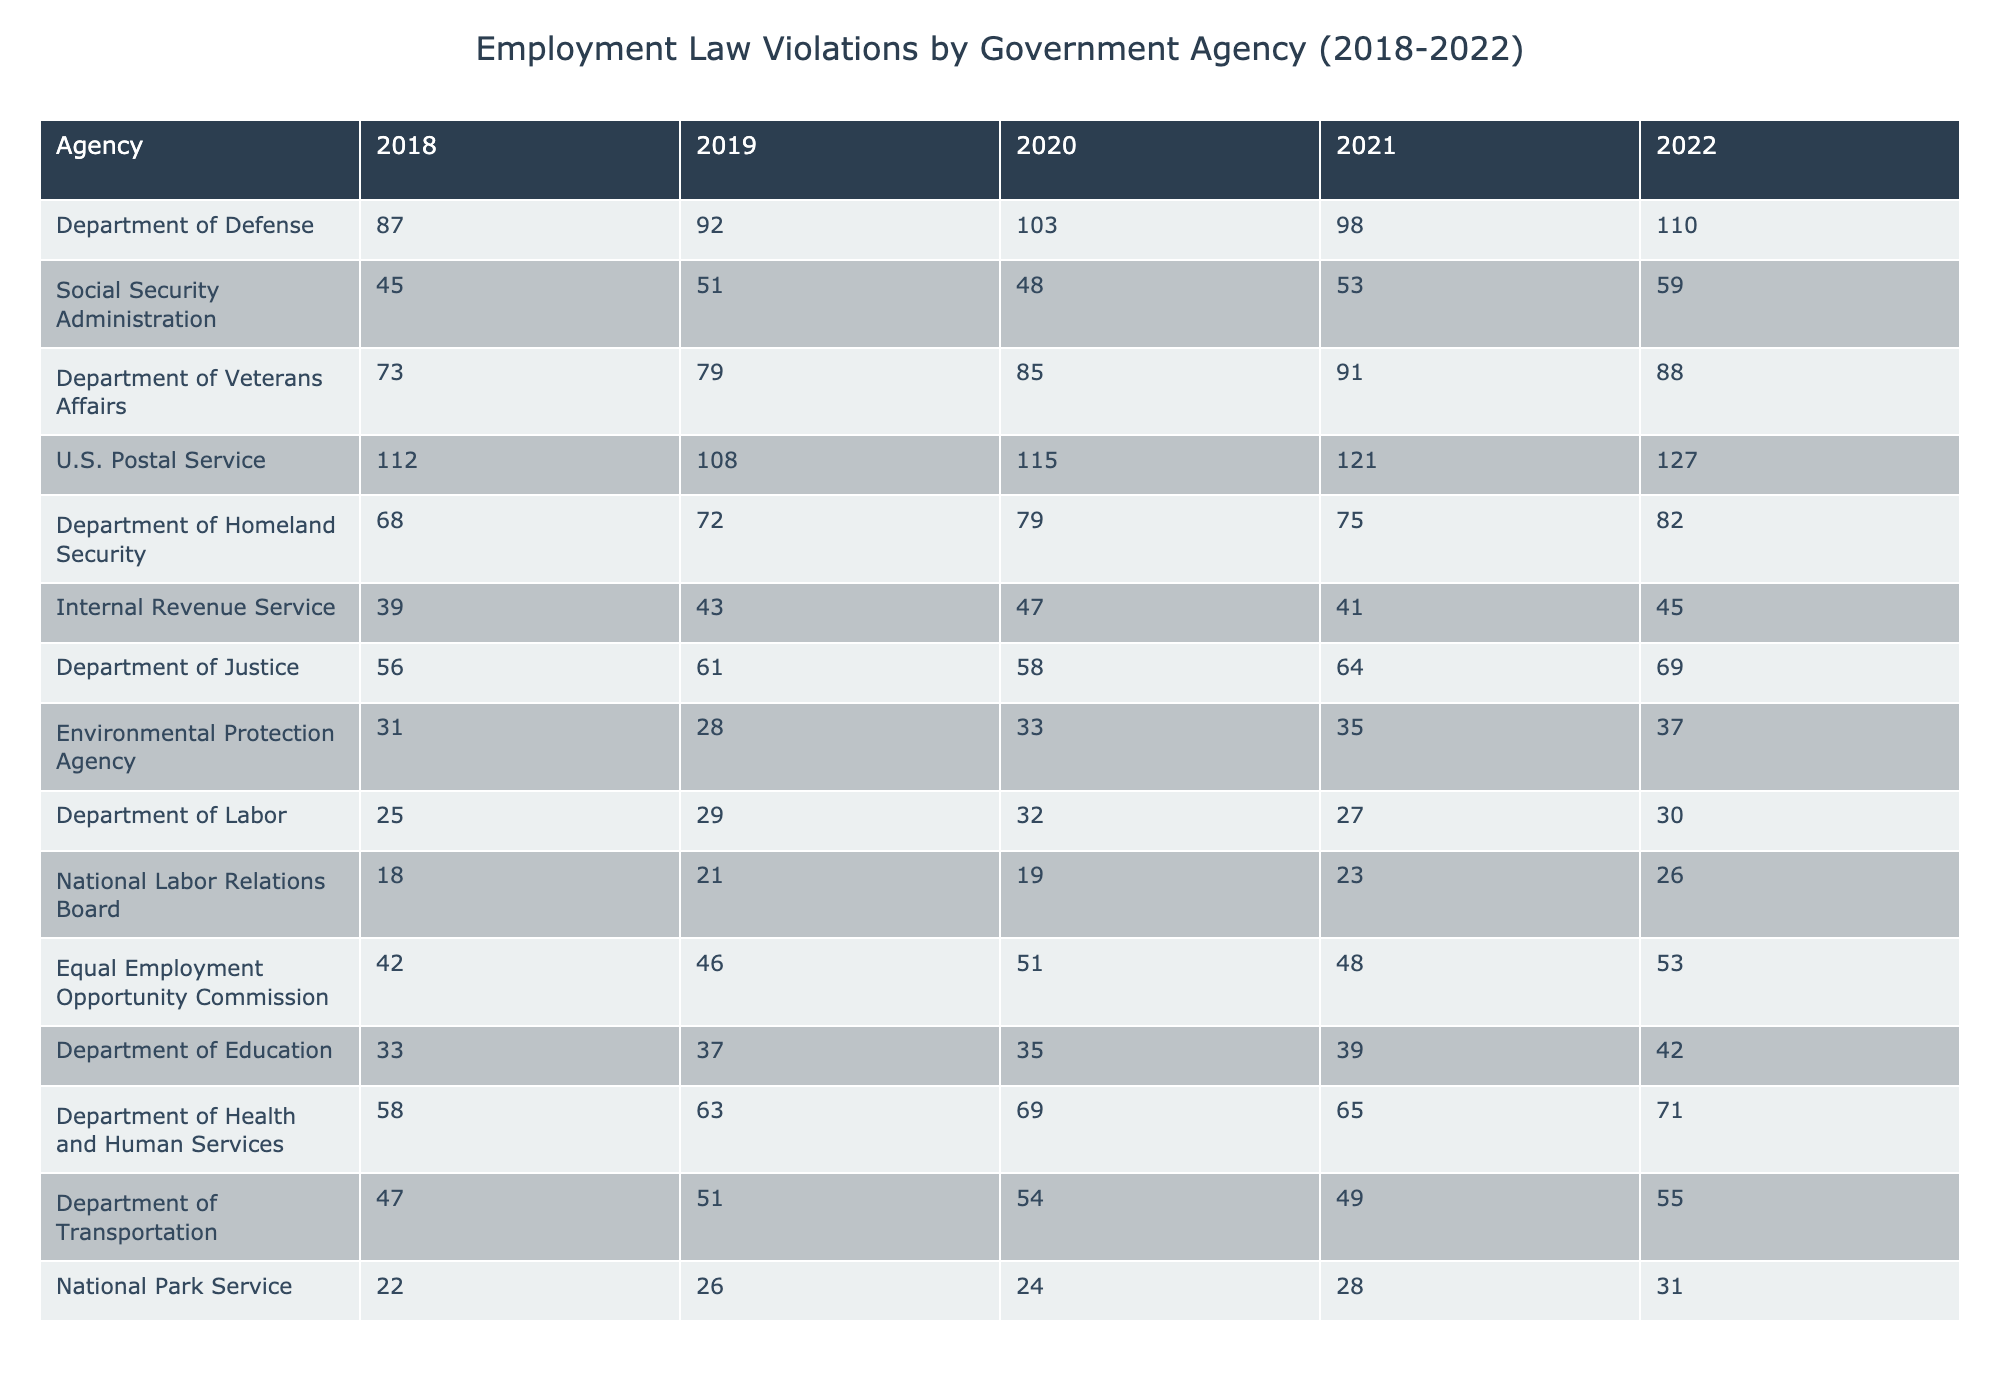What was the highest number of employment law violations reported by the U.S. Postal Service? Referring to the table, the highest number of violations reported by the U.S. Postal Service was 127 in 2022.
Answer: 127 Which agency had the lowest total of violations over the five years? Adding the violations for each agency from 2018 to 2022, the National Labor Relations Board had the lowest total with 105 violations.
Answer: National Labor Relations Board What was the average number of violations for the Department of Defense over the five years? The total number of violations for the Department of Defense from 2018 to 2022 is 490 (87 + 92 + 103 + 98 + 110). Dividing by 5 gives an average of 98.
Answer: 98 Did the Department of Labor see an increase or decrease in violations from 2018 to 2022? The Department of Labor had 25 violations in 2018 and 30 in 2022, showing an increase of 5 violations over the five years.
Answer: Increase What is the difference between the highest and lowest number of violations reported in 2021? The highest number of violations in 2021 was reported by the U.S. Postal Service (121), and the lowest was reported by the National Labor Relations Board (23). The difference is 121 - 23 = 98.
Answer: 98 In which years did the Department of Health and Human Services have more than 65 violations? The Department of Health and Human Services had violations exceeding 65 in the years 2020 (69), 2021 (65), and 2022 (71).
Answer: 2020, 2022 How many total violations were reported by the Environmental Protection Agency from 2018 to 2022? Summing the violations for the Environmental Protection Agency gives 31 + 28 + 33 + 35 + 37 = 164.
Answer: 164 What percentage of violations in 2022 were reported by the Department of Defense compared to the total violations across all agencies in the same year? The Department of Defense had 110 violations in 2022. Summing the total for 2022 across all agencies equals 703. Therefore, (110/703) * 100 = approximately 15.63%.
Answer: 15.63% Which agency consistently reported an increase in violations every year from 2018 to 2022? Analyzing the data, the U.S. Postal Service showed a consistent increase each year: 112, 108, 115, 121, 127, indicating that it increased every year.
Answer: U.S. Postal Service What was the trend in violations for the Department of Veterans Affairs over the last five years? The trend shows a general increase in violations from 73 in 2018 to a peak of 91 in 2021, followed by a drop to 88 in 2022, suggesting a mix of increase and decrease trend.
Answer: Fluctuating trend Which two agencies had the closest number of violations in the year 2019? In 2019, the Department of Defense reported 92 violations while the Department of Justice reported 61 violations. The closest numbers in that year were between the Department of Defense and the Social Security Administration (51).
Answer: Department of Defense and Social Security Administration What is the median number of violations for the Department of Transportation across the five years? The number of violations for the Department of Transportation over the years are: 47, 51, 54, 49, 55. When organized in ascending order, the middle number (median) is 51.
Answer: 51 